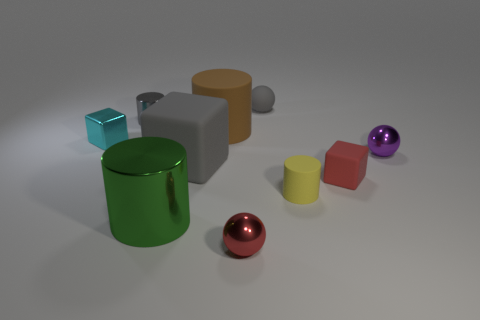The purple shiny thing that is the same shape as the tiny red metal object is what size?
Provide a succinct answer. Small. Do the big metallic thing and the small metallic cylinder have the same color?
Give a very brief answer. No. How many yellow rubber cylinders are behind the red shiny object left of the tiny red thing behind the large shiny cylinder?
Offer a very short reply. 1. Are there more big brown rubber cylinders than small objects?
Your answer should be very brief. No. How many big blue balls are there?
Provide a succinct answer. 0. The gray matte thing in front of the tiny object that is behind the tiny cylinder that is on the left side of the brown cylinder is what shape?
Offer a very short reply. Cube. Are there fewer tiny yellow objects that are behind the small gray metal thing than small red metal things to the right of the rubber sphere?
Provide a short and direct response. No. There is a small shiny object left of the tiny gray cylinder; does it have the same shape as the tiny gray thing that is to the left of the red metallic sphere?
Your response must be concise. No. What is the shape of the small red object behind the sphere that is on the left side of the matte sphere?
Provide a succinct answer. Cube. There is a metal thing that is the same color as the large rubber block; what is its size?
Ensure brevity in your answer.  Small. 